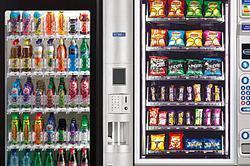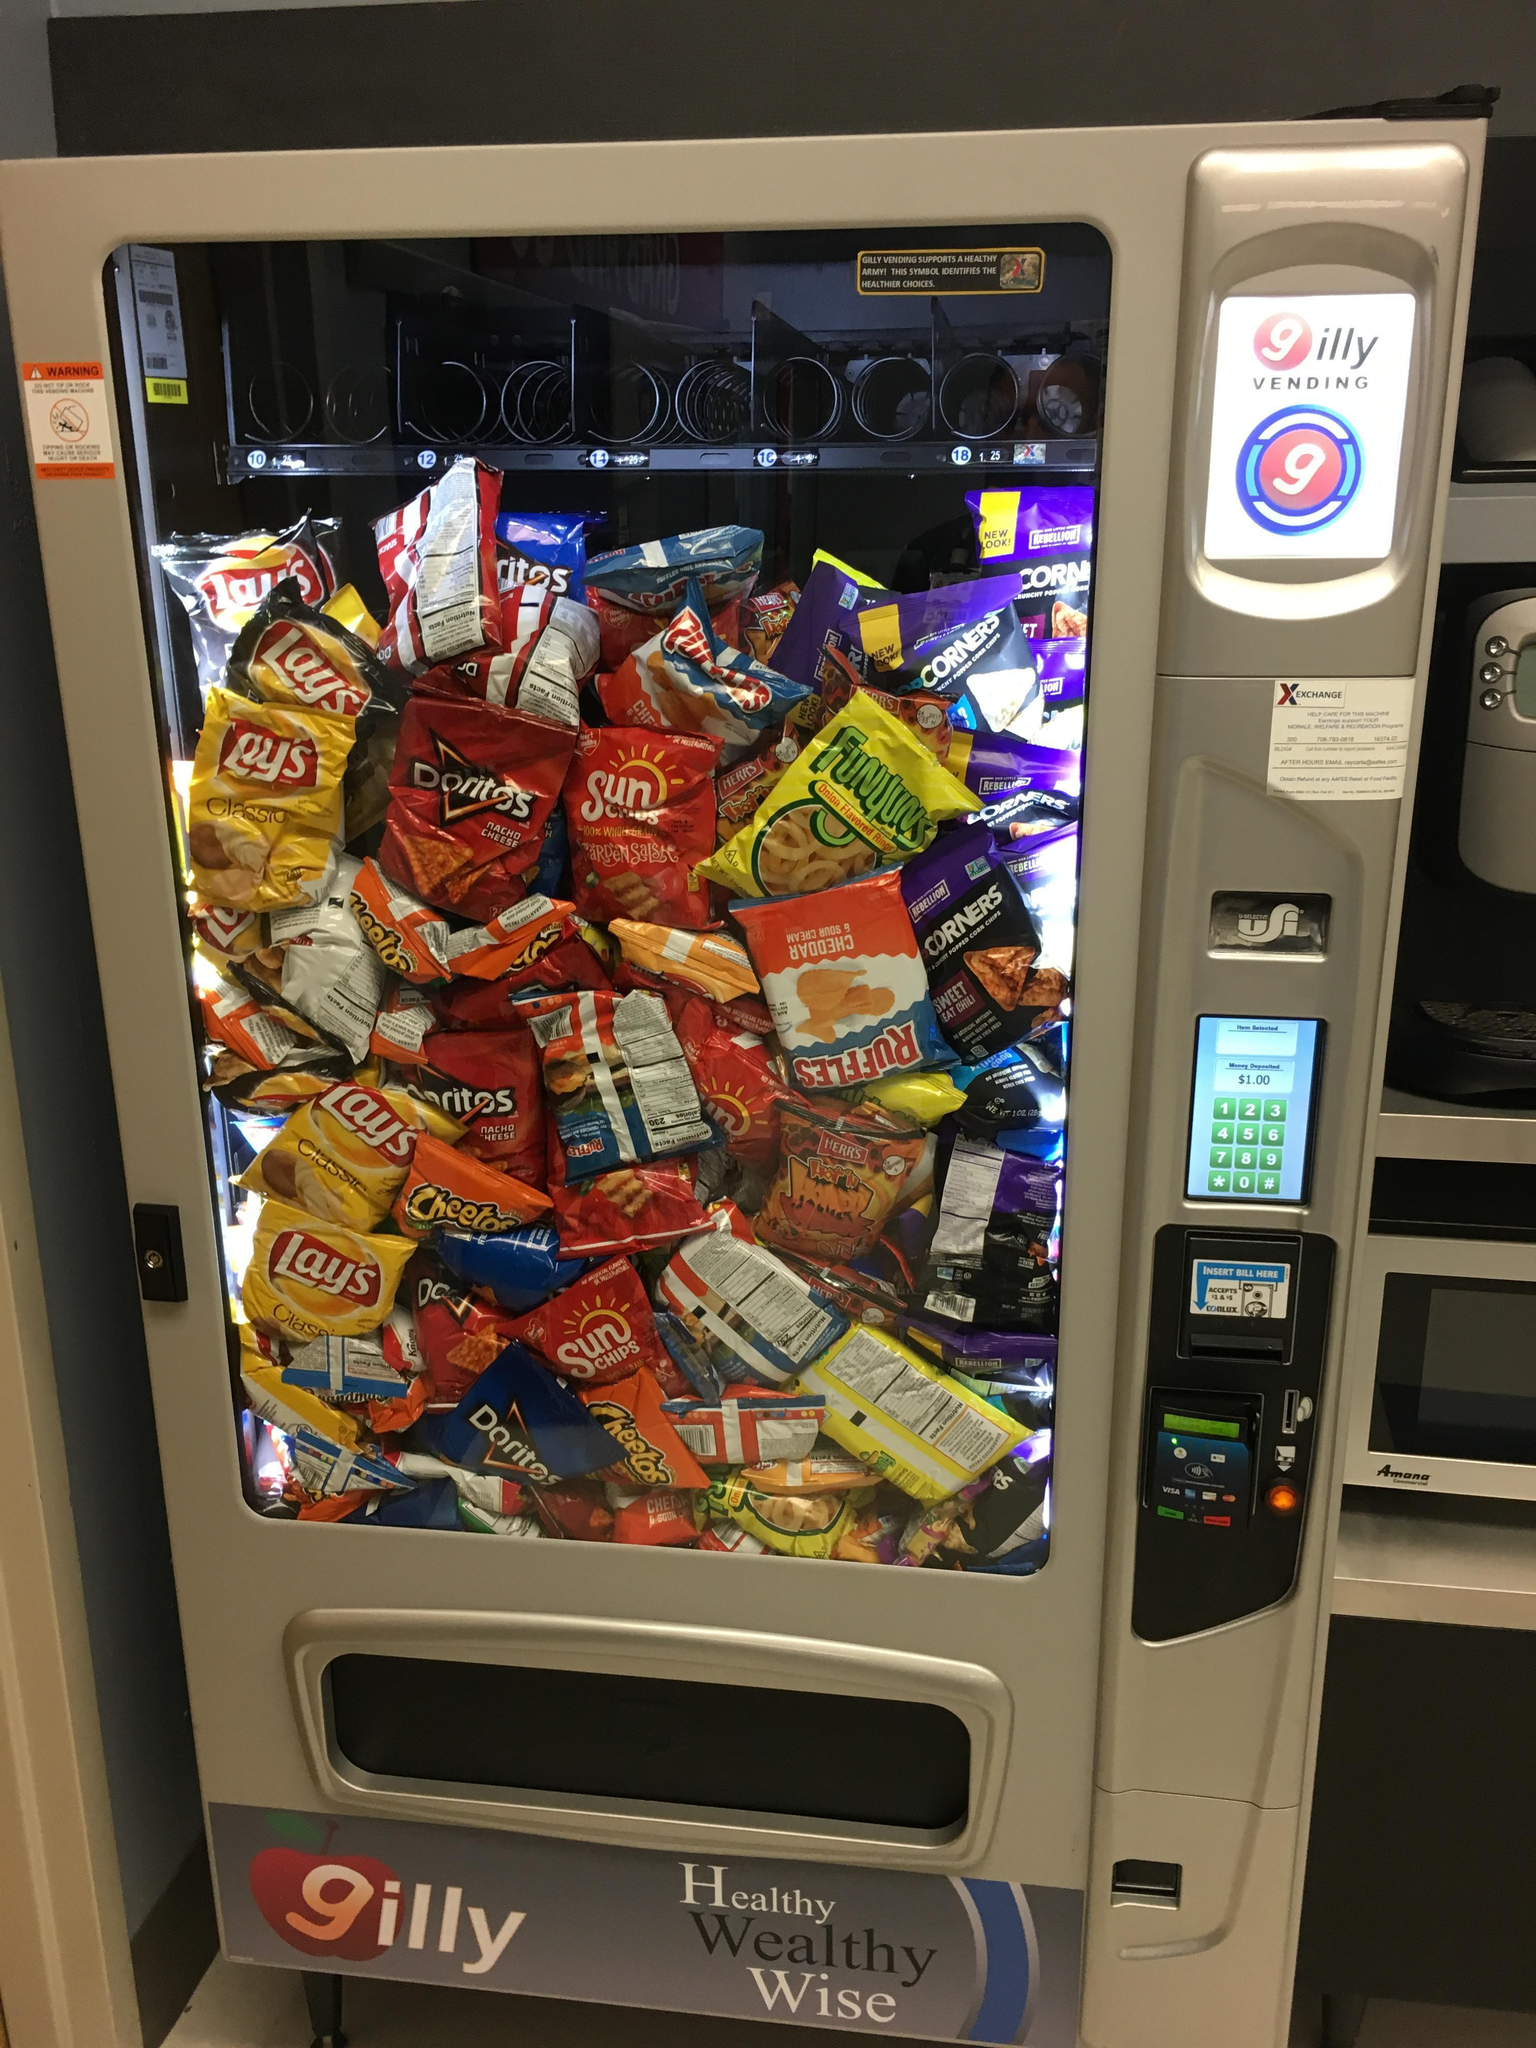The first image is the image on the left, the second image is the image on the right. Analyze the images presented: Is the assertion "There are at most three vending machines in total." valid? Answer yes or no. Yes. 